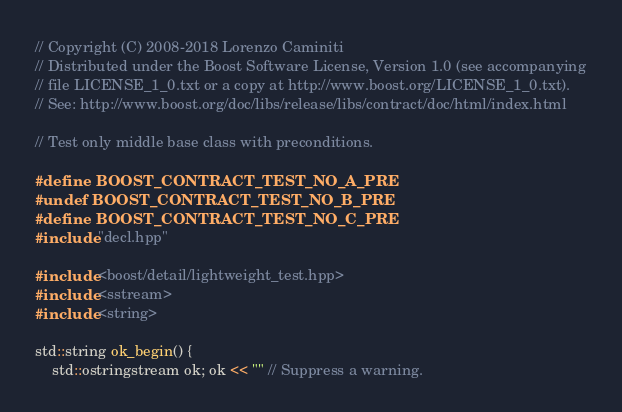<code> <loc_0><loc_0><loc_500><loc_500><_C++_>
// Copyright (C) 2008-2018 Lorenzo Caminiti
// Distributed under the Boost Software License, Version 1.0 (see accompanying
// file LICENSE_1_0.txt or a copy at http://www.boost.org/LICENSE_1_0.txt).
// See: http://www.boost.org/doc/libs/release/libs/contract/doc/html/index.html

// Test only middle base class with preconditions.

#define BOOST_CONTRACT_TEST_NO_A_PRE
#undef BOOST_CONTRACT_TEST_NO_B_PRE
#define BOOST_CONTRACT_TEST_NO_C_PRE
#include "decl.hpp"

#include <boost/detail/lightweight_test.hpp>
#include <sstream>
#include <string>

std::string ok_begin() {
    std::ostringstream ok; ok << "" // Suppress a warning.</code> 